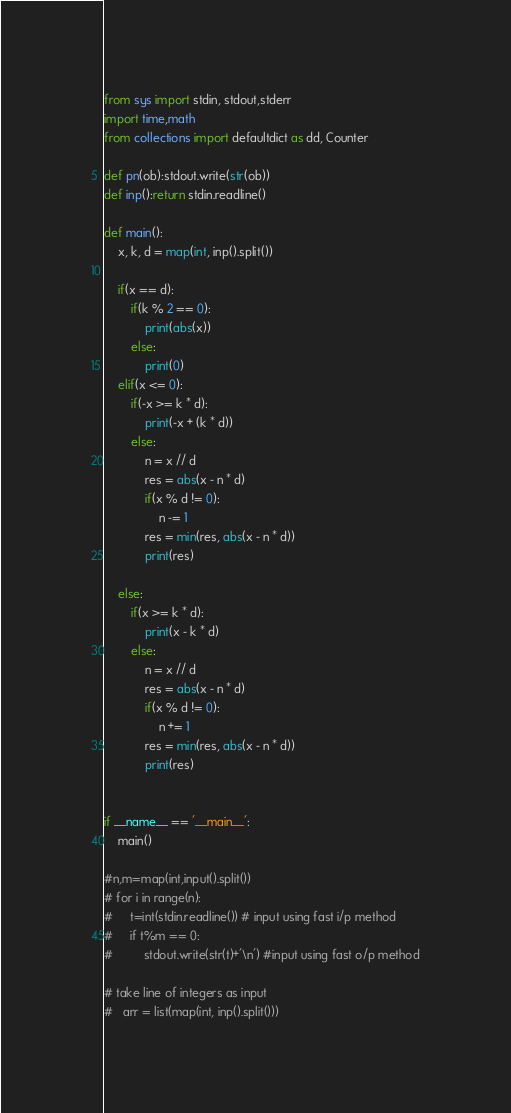<code> <loc_0><loc_0><loc_500><loc_500><_Python_>from sys import stdin, stdout,stderr
import time,math
from collections import defaultdict as dd, Counter
 
def pn(ob):stdout.write(str(ob))
def inp():return stdin.readline()
 
def main():
	x, k, d = map(int, inp().split())
	
	if(x == d):
		if(k % 2 == 0):
			print(abs(x))
		else:
			print(0)	
	elif(x <= 0):
		if(-x >= k * d):
			print(-x + (k * d))
		else:
			n = x // d
			res = abs(x - n * d)
			if(x % d != 0):
				n -= 1
			res = min(res, abs(x - n * d))
			print(res)

	else:
		if(x >= k * d):
			print(x - k * d)
		else:
			n = x // d
			res = abs(x - n * d)
			if(x % d != 0):
				n += 1
			res = min(res, abs(x - n * d))
			print(res)
		
  
if __name__ == '__main__':
	main()
	
#n,m=map(int,input().split()) 
# for i in range(n):
#     t=int(stdin.readline()) # input using fast i/p method 
#     if t%m == 0:
#         stdout.write(str(t)+'\n') #input using fast o/p method
 
# take line of integers as input
# 	arr = list(map(int, inp().split()))</code> 